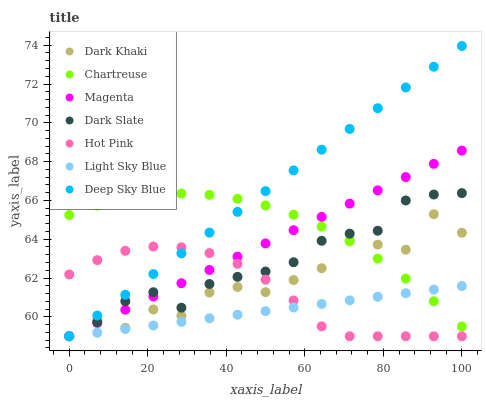Does Light Sky Blue have the minimum area under the curve?
Answer yes or no. Yes. Does Deep Sky Blue have the maximum area under the curve?
Answer yes or no. Yes. Does Dark Khaki have the minimum area under the curve?
Answer yes or no. No. Does Dark Khaki have the maximum area under the curve?
Answer yes or no. No. Is Light Sky Blue the smoothest?
Answer yes or no. Yes. Is Dark Khaki the roughest?
Answer yes or no. Yes. Is Dark Slate the smoothest?
Answer yes or no. No. Is Dark Slate the roughest?
Answer yes or no. No. Does Hot Pink have the lowest value?
Answer yes or no. Yes. Does Chartreuse have the lowest value?
Answer yes or no. No. Does Deep Sky Blue have the highest value?
Answer yes or no. Yes. Does Dark Khaki have the highest value?
Answer yes or no. No. Is Hot Pink less than Chartreuse?
Answer yes or no. Yes. Is Chartreuse greater than Hot Pink?
Answer yes or no. Yes. Does Dark Khaki intersect Magenta?
Answer yes or no. Yes. Is Dark Khaki less than Magenta?
Answer yes or no. No. Is Dark Khaki greater than Magenta?
Answer yes or no. No. Does Hot Pink intersect Chartreuse?
Answer yes or no. No. 